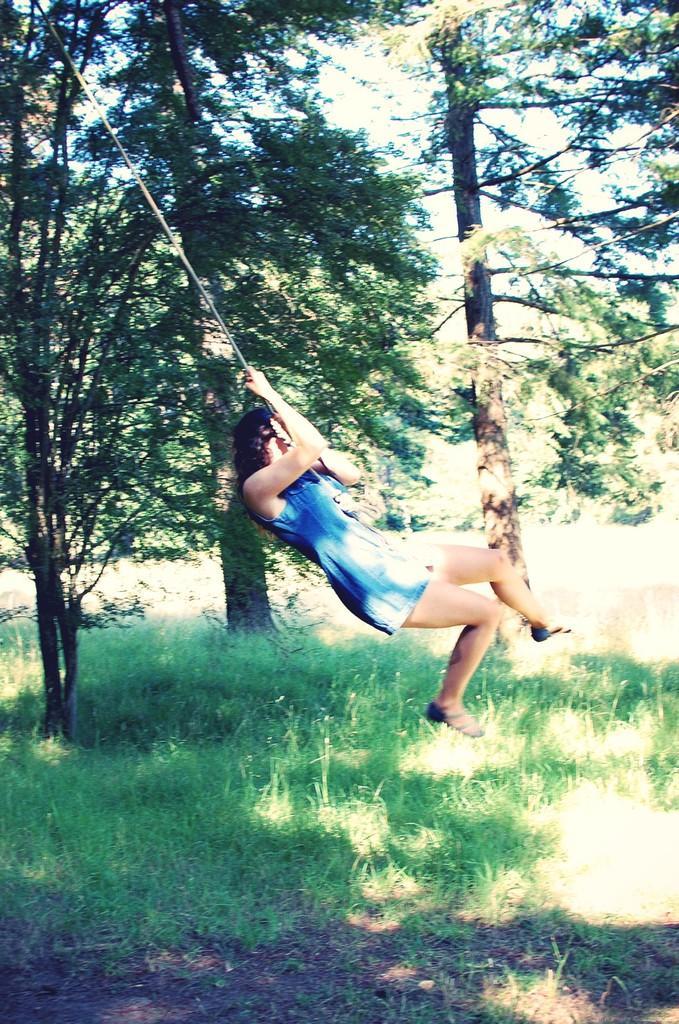Can you describe this image briefly? In this image we can see a girl wearing a dress is holding a rope in her hands. In the background, we can see a group of trees and sky. 